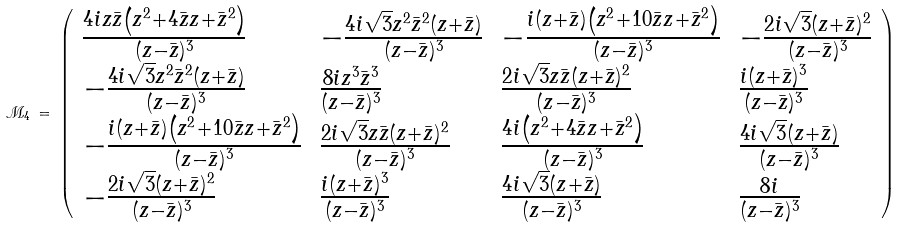<formula> <loc_0><loc_0><loc_500><loc_500>\mathcal { M } _ { 4 } \, = \, \left ( \begin{array} { l l l l } \frac { 4 i z { \bar { z } } \left ( z ^ { 2 } + 4 { \bar { z } } z + { \bar { z } } ^ { 2 } \right ) } { ( z - { \bar { z } } ) ^ { 3 } } & - \frac { 4 i \sqrt { 3 } z ^ { 2 } { \bar { z } } ^ { 2 } ( z + { \bar { z } } ) } { ( z - { \bar { z } } ) ^ { 3 } } & - \frac { i ( z + { \bar { z } } ) \left ( z ^ { 2 } + 1 0 { \bar { z } } z + { \bar { z } } ^ { 2 } \right ) } { ( z - { \bar { z } } ) ^ { 3 } } & - \frac { 2 i \sqrt { 3 } ( z + { \bar { z } } ) ^ { 2 } } { ( z - { \bar { z } } ) ^ { 3 } } \\ - \frac { 4 i \sqrt { 3 } z ^ { 2 } { \bar { z } } ^ { 2 } ( z + { \bar { z } } ) } { ( z - { \bar { z } } ) ^ { 3 } } & \frac { 8 i z ^ { 3 } { \bar { z } } ^ { 3 } } { ( z - { \bar { z } } ) ^ { 3 } } & \frac { 2 i \sqrt { 3 } z { \bar { z } } ( z + { \bar { z } } ) ^ { 2 } } { ( z - { \bar { z } } ) ^ { 3 } } & \frac { i ( z + { \bar { z } } ) ^ { 3 } } { ( z - { \bar { z } } ) ^ { 3 } } \\ - \frac { i ( z + { \bar { z } } ) \left ( z ^ { 2 } + 1 0 { \bar { z } } z + { \bar { z } } ^ { 2 } \right ) } { ( z - { \bar { z } } ) ^ { 3 } } & \frac { 2 i \sqrt { 3 } z { \bar { z } } ( z + { \bar { z } } ) ^ { 2 } } { ( z - { \bar { z } } ) ^ { 3 } } & \frac { 4 i \left ( z ^ { 2 } + 4 { \bar { z } } z + { \bar { z } } ^ { 2 } \right ) } { ( z - { \bar { z } } ) ^ { 3 } } & \frac { 4 i \sqrt { 3 } ( z + { \bar { z } } ) } { ( z - { \bar { z } } ) ^ { 3 } } \\ - \frac { 2 i \sqrt { 3 } ( z + { \bar { z } } ) ^ { 2 } } { ( z - { \bar { z } } ) ^ { 3 } } & \frac { i ( z + { \bar { z } } ) ^ { 3 } } { ( z - { \bar { z } } ) ^ { 3 } } & \frac { 4 i \sqrt { 3 } ( z + { \bar { z } } ) } { ( z - { \bar { z } } ) ^ { 3 } } & \frac { 8 i } { ( z - { \bar { z } } ) ^ { 3 } } \end{array} \right )</formula> 